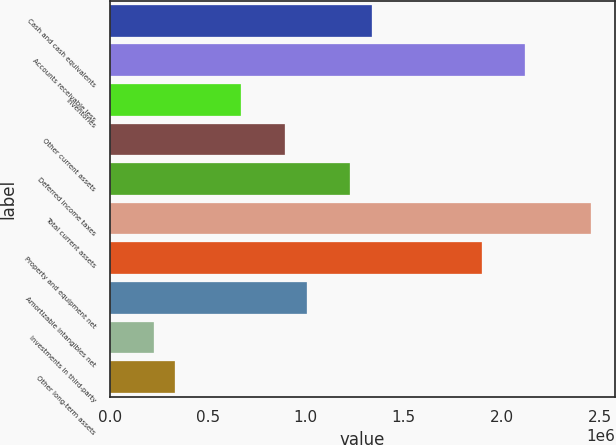Convert chart. <chart><loc_0><loc_0><loc_500><loc_500><bar_chart><fcel>Cash and cash equivalents<fcel>Accounts receivable less<fcel>Inventories<fcel>Other current assets<fcel>Deferred income taxes<fcel>Total current assets<fcel>Property and equipment net<fcel>Amortizable intangibles net<fcel>Investments in third-party<fcel>Other long-term assets<nl><fcel>1.34038e+06<fcel>2.12218e+06<fcel>670255<fcel>893629<fcel>1.22869e+06<fcel>2.45724e+06<fcel>1.89881e+06<fcel>1.00532e+06<fcel>223508<fcel>335195<nl></chart> 